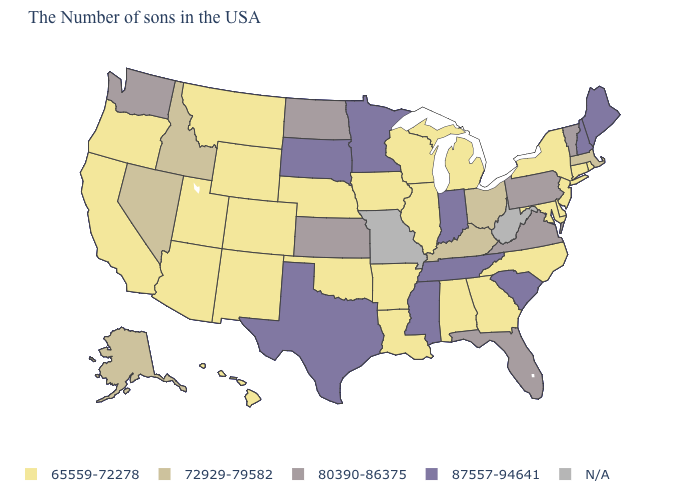What is the lowest value in the Northeast?
Quick response, please. 65559-72278. Among the states that border Nevada , which have the lowest value?
Keep it brief. Utah, Arizona, California, Oregon. Among the states that border Delaware , which have the highest value?
Keep it brief. Pennsylvania. What is the value of Arizona?
Write a very short answer. 65559-72278. What is the value of Illinois?
Write a very short answer. 65559-72278. Does the map have missing data?
Concise answer only. Yes. What is the value of Colorado?
Write a very short answer. 65559-72278. Among the states that border Pennsylvania , does Maryland have the highest value?
Concise answer only. No. Does the first symbol in the legend represent the smallest category?
Short answer required. Yes. Is the legend a continuous bar?
Short answer required. No. Name the states that have a value in the range N/A?
Give a very brief answer. West Virginia, Missouri. What is the value of Arizona?
Be succinct. 65559-72278. Which states have the highest value in the USA?
Keep it brief. Maine, New Hampshire, South Carolina, Indiana, Tennessee, Mississippi, Minnesota, Texas, South Dakota. Name the states that have a value in the range 87557-94641?
Concise answer only. Maine, New Hampshire, South Carolina, Indiana, Tennessee, Mississippi, Minnesota, Texas, South Dakota. 